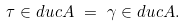Convert formula to latex. <formula><loc_0><loc_0><loc_500><loc_500>\tau \in d u c A \ = \ \gamma \in d u c A .</formula> 